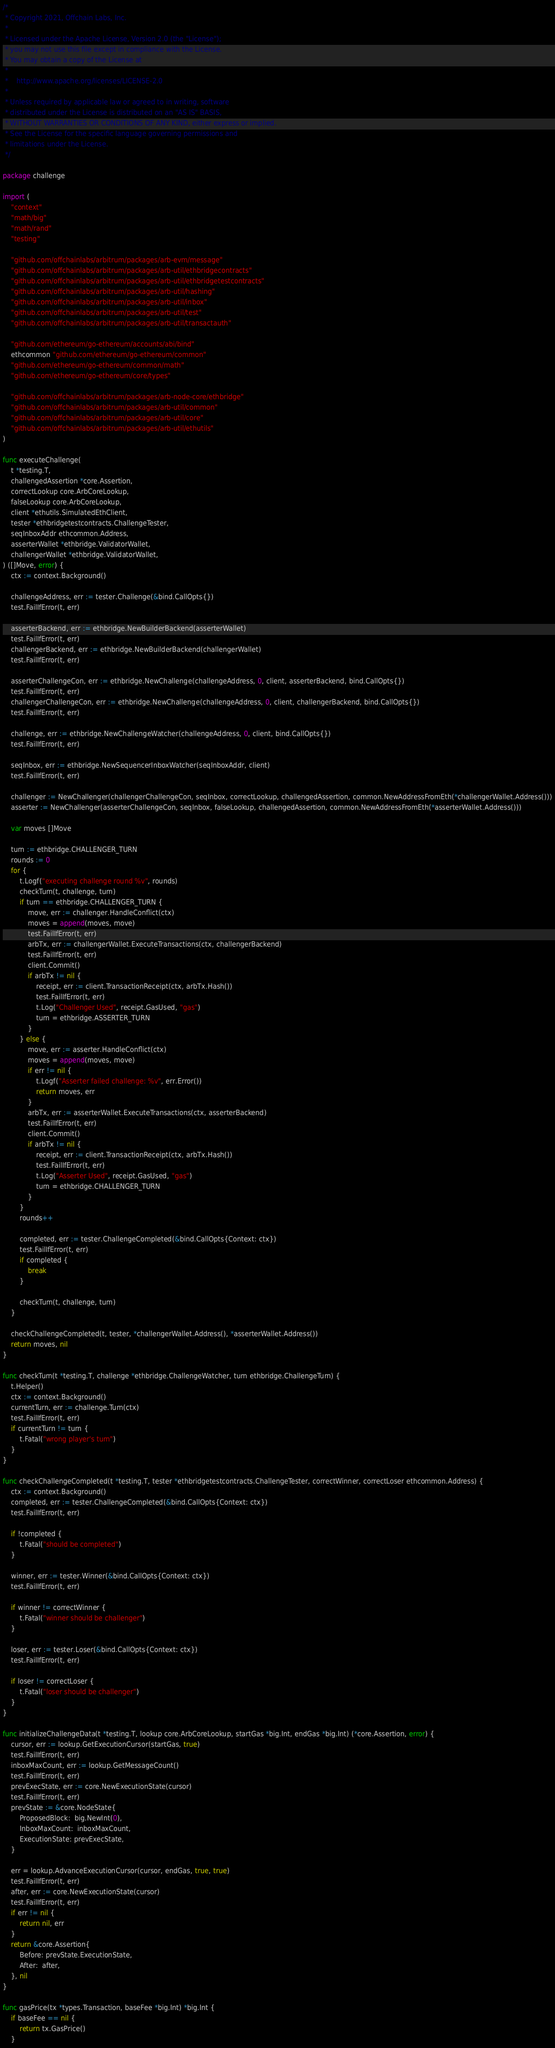<code> <loc_0><loc_0><loc_500><loc_500><_Go_>/*
 * Copyright 2021, Offchain Labs, Inc.
 *
 * Licensed under the Apache License, Version 2.0 (the "License");
 * you may not use this file except in compliance with the License.
 * You may obtain a copy of the License at
 *
 *    http://www.apache.org/licenses/LICENSE-2.0
 *
 * Unless required by applicable law or agreed to in writing, software
 * distributed under the License is distributed on an "AS IS" BASIS,
 * WITHOUT WARRANTIES OR CONDITIONS OF ANY KIND, either express or implied.
 * See the License for the specific language governing permissions and
 * limitations under the License.
 */

package challenge

import (
	"context"
	"math/big"
	"math/rand"
	"testing"

	"github.com/offchainlabs/arbitrum/packages/arb-evm/message"
	"github.com/offchainlabs/arbitrum/packages/arb-util/ethbridgecontracts"
	"github.com/offchainlabs/arbitrum/packages/arb-util/ethbridgetestcontracts"
	"github.com/offchainlabs/arbitrum/packages/arb-util/hashing"
	"github.com/offchainlabs/arbitrum/packages/arb-util/inbox"
	"github.com/offchainlabs/arbitrum/packages/arb-util/test"
	"github.com/offchainlabs/arbitrum/packages/arb-util/transactauth"

	"github.com/ethereum/go-ethereum/accounts/abi/bind"
	ethcommon "github.com/ethereum/go-ethereum/common"
	"github.com/ethereum/go-ethereum/common/math"
	"github.com/ethereum/go-ethereum/core/types"

	"github.com/offchainlabs/arbitrum/packages/arb-node-core/ethbridge"
	"github.com/offchainlabs/arbitrum/packages/arb-util/common"
	"github.com/offchainlabs/arbitrum/packages/arb-util/core"
	"github.com/offchainlabs/arbitrum/packages/arb-util/ethutils"
)

func executeChallenge(
	t *testing.T,
	challengedAssertion *core.Assertion,
	correctLookup core.ArbCoreLookup,
	falseLookup core.ArbCoreLookup,
	client *ethutils.SimulatedEthClient,
	tester *ethbridgetestcontracts.ChallengeTester,
	seqInboxAddr ethcommon.Address,
	asserterWallet *ethbridge.ValidatorWallet,
	challengerWallet *ethbridge.ValidatorWallet,
) ([]Move, error) {
	ctx := context.Background()

	challengeAddress, err := tester.Challenge(&bind.CallOpts{})
	test.FailIfError(t, err)

	asserterBackend, err := ethbridge.NewBuilderBackend(asserterWallet)
	test.FailIfError(t, err)
	challengerBackend, err := ethbridge.NewBuilderBackend(challengerWallet)
	test.FailIfError(t, err)

	asserterChallengeCon, err := ethbridge.NewChallenge(challengeAddress, 0, client, asserterBackend, bind.CallOpts{})
	test.FailIfError(t, err)
	challengerChallengeCon, err := ethbridge.NewChallenge(challengeAddress, 0, client, challengerBackend, bind.CallOpts{})
	test.FailIfError(t, err)

	challenge, err := ethbridge.NewChallengeWatcher(challengeAddress, 0, client, bind.CallOpts{})
	test.FailIfError(t, err)

	seqInbox, err := ethbridge.NewSequencerInboxWatcher(seqInboxAddr, client)
	test.FailIfError(t, err)

	challenger := NewChallenger(challengerChallengeCon, seqInbox, correctLookup, challengedAssertion, common.NewAddressFromEth(*challengerWallet.Address()))
	asserter := NewChallenger(asserterChallengeCon, seqInbox, falseLookup, challengedAssertion, common.NewAddressFromEth(*asserterWallet.Address()))

	var moves []Move

	turn := ethbridge.CHALLENGER_TURN
	rounds := 0
	for {
		t.Logf("executing challenge round %v", rounds)
		checkTurn(t, challenge, turn)
		if turn == ethbridge.CHALLENGER_TURN {
			move, err := challenger.HandleConflict(ctx)
			moves = append(moves, move)
			test.FailIfError(t, err)
			arbTx, err := challengerWallet.ExecuteTransactions(ctx, challengerBackend)
			test.FailIfError(t, err)
			client.Commit()
			if arbTx != nil {
				receipt, err := client.TransactionReceipt(ctx, arbTx.Hash())
				test.FailIfError(t, err)
				t.Log("Challenger Used", receipt.GasUsed, "gas")
				turn = ethbridge.ASSERTER_TURN
			}
		} else {
			move, err := asserter.HandleConflict(ctx)
			moves = append(moves, move)
			if err != nil {
				t.Logf("Asserter failed challenge: %v", err.Error())
				return moves, err
			}
			arbTx, err := asserterWallet.ExecuteTransactions(ctx, asserterBackend)
			test.FailIfError(t, err)
			client.Commit()
			if arbTx != nil {
				receipt, err := client.TransactionReceipt(ctx, arbTx.Hash())
				test.FailIfError(t, err)
				t.Log("Asserter Used", receipt.GasUsed, "gas")
				turn = ethbridge.CHALLENGER_TURN
			}
		}
		rounds++

		completed, err := tester.ChallengeCompleted(&bind.CallOpts{Context: ctx})
		test.FailIfError(t, err)
		if completed {
			break
		}

		checkTurn(t, challenge, turn)
	}

	checkChallengeCompleted(t, tester, *challengerWallet.Address(), *asserterWallet.Address())
	return moves, nil
}

func checkTurn(t *testing.T, challenge *ethbridge.ChallengeWatcher, turn ethbridge.ChallengeTurn) {
	t.Helper()
	ctx := context.Background()
	currentTurn, err := challenge.Turn(ctx)
	test.FailIfError(t, err)
	if currentTurn != turn {
		t.Fatal("wrong player's turn")
	}
}

func checkChallengeCompleted(t *testing.T, tester *ethbridgetestcontracts.ChallengeTester, correctWinner, correctLoser ethcommon.Address) {
	ctx := context.Background()
	completed, err := tester.ChallengeCompleted(&bind.CallOpts{Context: ctx})
	test.FailIfError(t, err)

	if !completed {
		t.Fatal("should be completed")
	}

	winner, err := tester.Winner(&bind.CallOpts{Context: ctx})
	test.FailIfError(t, err)

	if winner != correctWinner {
		t.Fatal("winner should be challenger")
	}

	loser, err := tester.Loser(&bind.CallOpts{Context: ctx})
	test.FailIfError(t, err)

	if loser != correctLoser {
		t.Fatal("loser should be challenger")
	}
}

func initializeChallengeData(t *testing.T, lookup core.ArbCoreLookup, startGas *big.Int, endGas *big.Int) (*core.Assertion, error) {
	cursor, err := lookup.GetExecutionCursor(startGas, true)
	test.FailIfError(t, err)
	inboxMaxCount, err := lookup.GetMessageCount()
	test.FailIfError(t, err)
	prevExecState, err := core.NewExecutionState(cursor)
	test.FailIfError(t, err)
	prevState := &core.NodeState{
		ProposedBlock:  big.NewInt(0),
		InboxMaxCount:  inboxMaxCount,
		ExecutionState: prevExecState,
	}

	err = lookup.AdvanceExecutionCursor(cursor, endGas, true, true)
	test.FailIfError(t, err)
	after, err := core.NewExecutionState(cursor)
	test.FailIfError(t, err)
	if err != nil {
		return nil, err
	}
	return &core.Assertion{
		Before: prevState.ExecutionState,
		After:  after,
	}, nil
}

func gasPrice(tx *types.Transaction, baseFee *big.Int) *big.Int {
	if baseFee == nil {
		return tx.GasPrice()
	}</code> 